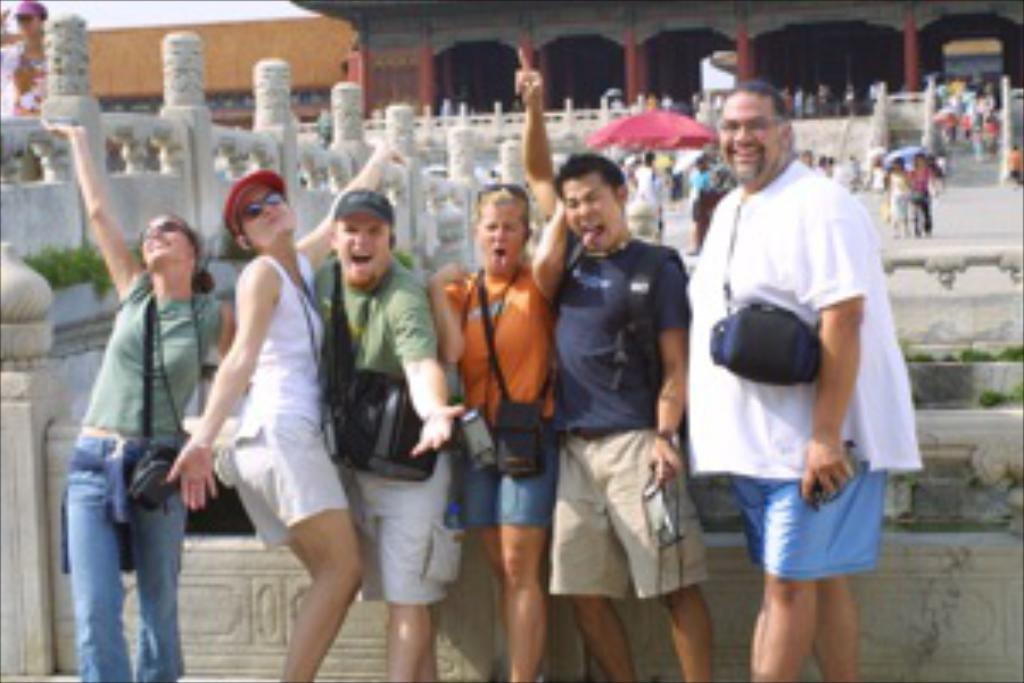What are the people in the image doing? There is a group of persons standing on the floor in the image. What can be seen in the background of the image? There is a building, persons, stairs, fencing, and the sky visible in the background of the image. Can you see a rabbit attacking the fence in the image? No, there is no rabbit or attack visible in the image. 